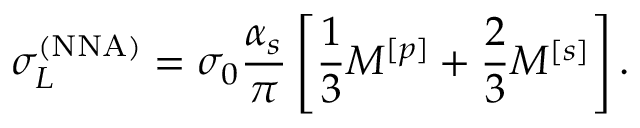<formula> <loc_0><loc_0><loc_500><loc_500>\sigma _ { L } ^ { ( N N A ) } = \sigma _ { 0 } \frac { \alpha _ { s } } { \pi } \left [ \frac { 1 } { 3 } M ^ { [ p ] } + \frac { 2 } { 3 } M ^ { [ s ] } \right ] .</formula> 